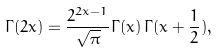<formula> <loc_0><loc_0><loc_500><loc_500>\Gamma ( 2 x ) = \frac { 2 ^ { 2 x - 1 } } { \sqrt { \pi } } \Gamma ( x ) \, \Gamma ( x + \frac { 1 } { 2 } ) ,</formula> 